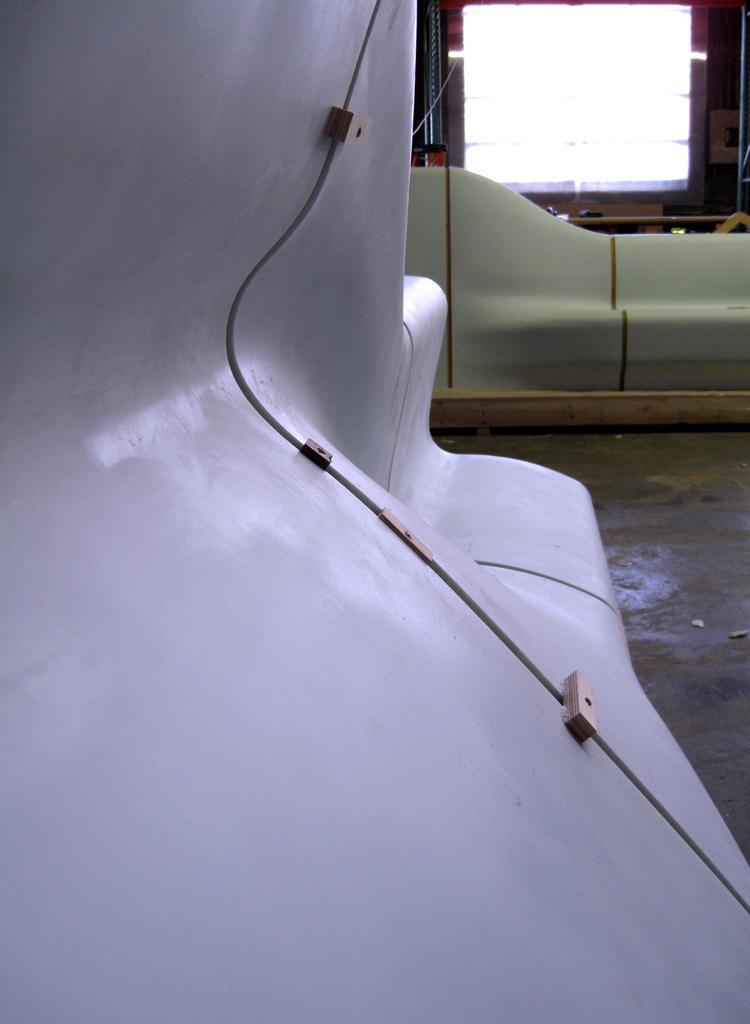Describe this image in one or two sentences. Here in this picture we can see some metal things present on the floor here and there and at the top we can see a window present over there. 